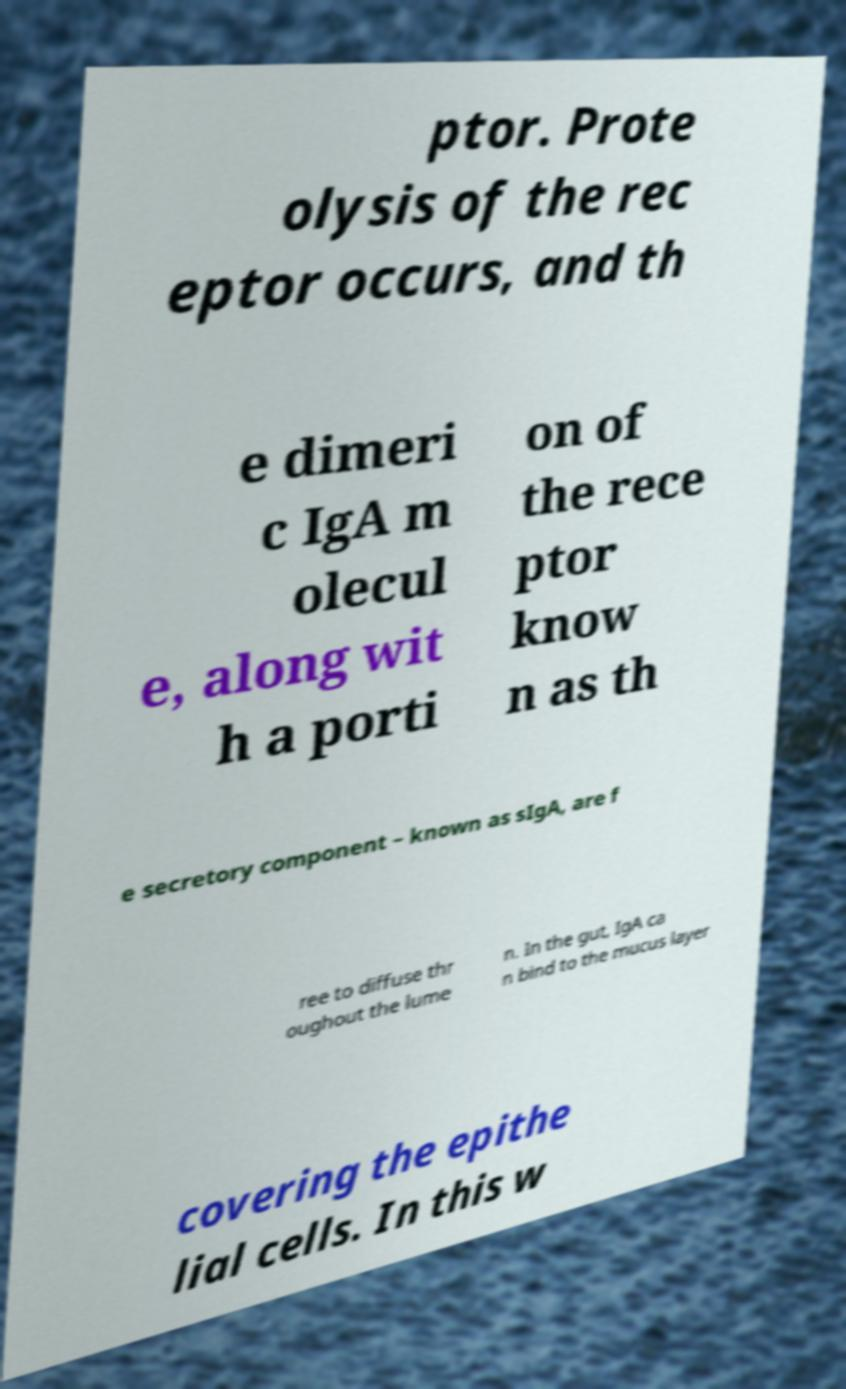Can you read and provide the text displayed in the image?This photo seems to have some interesting text. Can you extract and type it out for me? ptor. Prote olysis of the rec eptor occurs, and th e dimeri c IgA m olecul e, along wit h a porti on of the rece ptor know n as th e secretory component – known as sIgA, are f ree to diffuse thr oughout the lume n. In the gut, IgA ca n bind to the mucus layer covering the epithe lial cells. In this w 